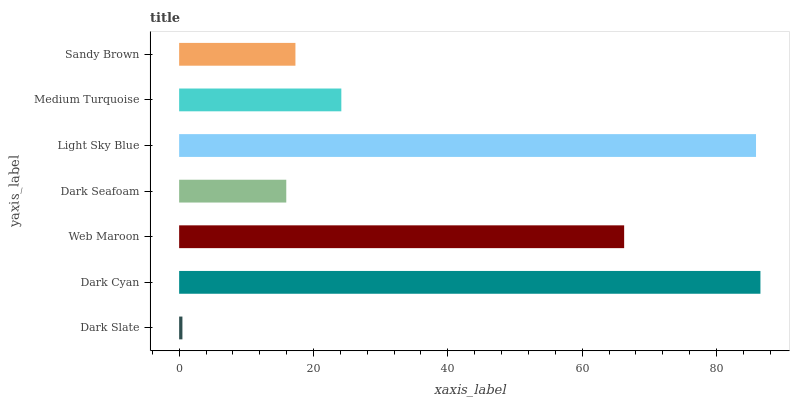Is Dark Slate the minimum?
Answer yes or no. Yes. Is Dark Cyan the maximum?
Answer yes or no. Yes. Is Web Maroon the minimum?
Answer yes or no. No. Is Web Maroon the maximum?
Answer yes or no. No. Is Dark Cyan greater than Web Maroon?
Answer yes or no. Yes. Is Web Maroon less than Dark Cyan?
Answer yes or no. Yes. Is Web Maroon greater than Dark Cyan?
Answer yes or no. No. Is Dark Cyan less than Web Maroon?
Answer yes or no. No. Is Medium Turquoise the high median?
Answer yes or no. Yes. Is Medium Turquoise the low median?
Answer yes or no. Yes. Is Dark Cyan the high median?
Answer yes or no. No. Is Web Maroon the low median?
Answer yes or no. No. 